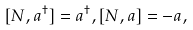<formula> <loc_0><loc_0><loc_500><loc_500>[ N , a ^ { \dagger } ] = a ^ { \dagger } , [ N , a ] = - a ,</formula> 